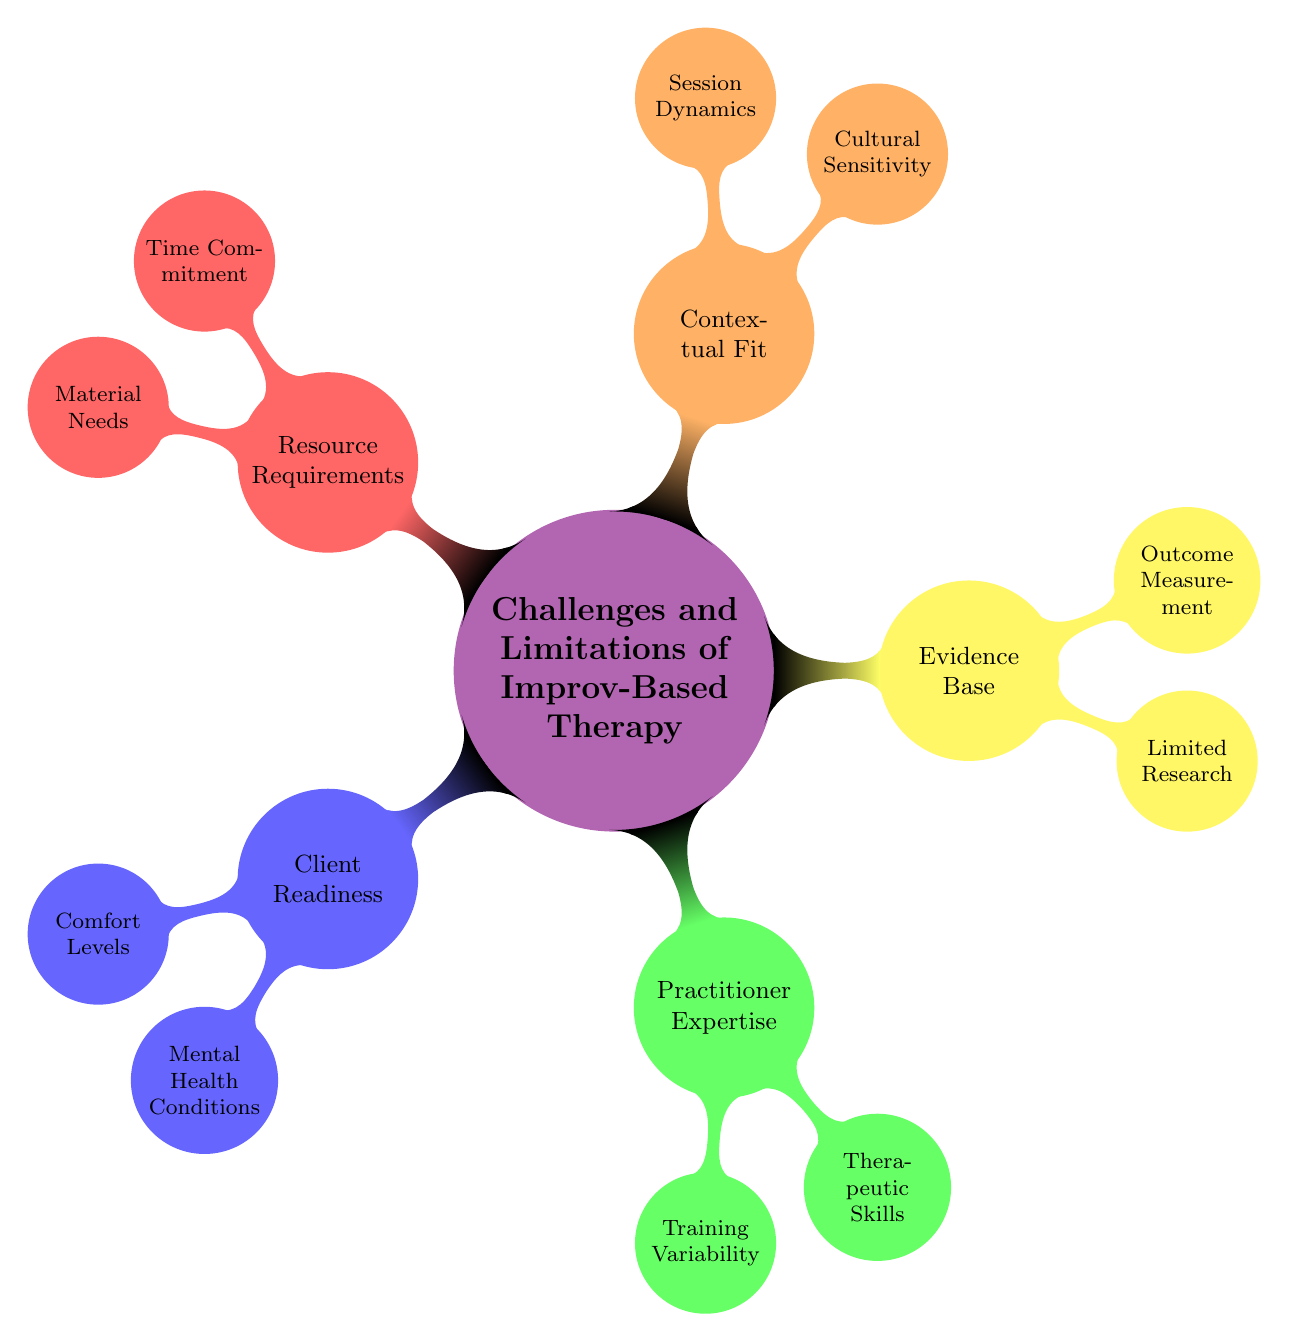What is the main topic of the mind map? The central node of the mind map explicitly states "Challenges and Limitations of Improv-Based Therapy" as the main topic, which is the focus of all the other nodes surrounding it.
Answer: Challenges and Limitations of Improv-Based Therapy How many main categories are there in the diagram? There are a total of five main categories branching out from the central node, which represent different challenges and limitations. By counting each of the main child nodes, we find that there are five distinct categories.
Answer: 5 What is one challenge related to client readiness? Under the "Client Readiness" category, the diagram lists "Comfort Levels" and "Mental Health Conditions" as sub-challenges. Either of these can be considered one challenge related to client readiness.
Answer: Comfort Levels Which category includes "Limited Research"? The node labeled "Limited Research" is found under the "Evidence Base" category, indicating it is related to the challenges of substantiating the therapy's effectiveness.
Answer: Evidence Base Which two aspects are mentioned under "Practitioner Expertise"? The "Practitioner Expertise" category has two branches: "Training Variability" and "Therapeutic Skills," highlighting different aspects of the challenges faced by therapists in improv-based therapy.
Answer: Training Variability, Therapeutic Skills How does "Cultural Sensitivity" relate to improv-based therapy? "Cultural Sensitivity" is listed as a sub-node under the "Contextual Fit" category, pointing to the challenge of needing to adapt improv-based techniques to various cultural contexts to ensure effectiveness.
Answer: Contextual Fit What are the resource requirements stated in the diagram? The "Resource Requirements" category encompasses two critical sub-nodes: "Time Commitment" and "Material Needs," both of which signify the necessary resources for implementing improv-based therapy effectively.
Answer: Time Commitment, Material Needs Which challenge might affect the effectiveness of improv therapy due to group dynamics? The node "Session Dynamics" reflects how group dynamics can significantly influence individual outcomes of therapy, indicating a potential challenge in the effectiveness of improv therapy in group settings.
Answer: Session Dynamics How might the absence of rigorous empirical studies affect the use of improv-based therapy? The "Limited Research" sub-node under "Evidence Base" points out the challenge of a lack of rigorous empirical studies, which may lead to skepticism about the method's effectiveness and hinder its acceptance in the therapeutic community.
Answer: Limited Research What is one main limitation when measuring outcomes in improv-based therapy? The sub-node "Outcome Measurement" under "Evidence Base" indicates that difficulties in quantifying and measuring therapeutic outcomes present a limitation to using improv-based therapy effectively.
Answer: Outcome Measurement 